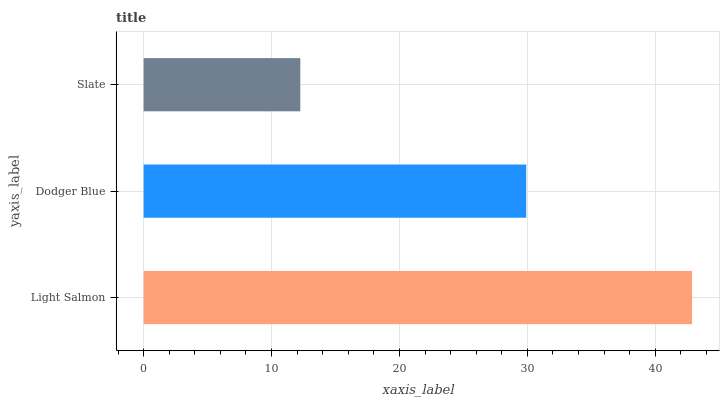Is Slate the minimum?
Answer yes or no. Yes. Is Light Salmon the maximum?
Answer yes or no. Yes. Is Dodger Blue the minimum?
Answer yes or no. No. Is Dodger Blue the maximum?
Answer yes or no. No. Is Light Salmon greater than Dodger Blue?
Answer yes or no. Yes. Is Dodger Blue less than Light Salmon?
Answer yes or no. Yes. Is Dodger Blue greater than Light Salmon?
Answer yes or no. No. Is Light Salmon less than Dodger Blue?
Answer yes or no. No. Is Dodger Blue the high median?
Answer yes or no. Yes. Is Dodger Blue the low median?
Answer yes or no. Yes. Is Light Salmon the high median?
Answer yes or no. No. Is Light Salmon the low median?
Answer yes or no. No. 